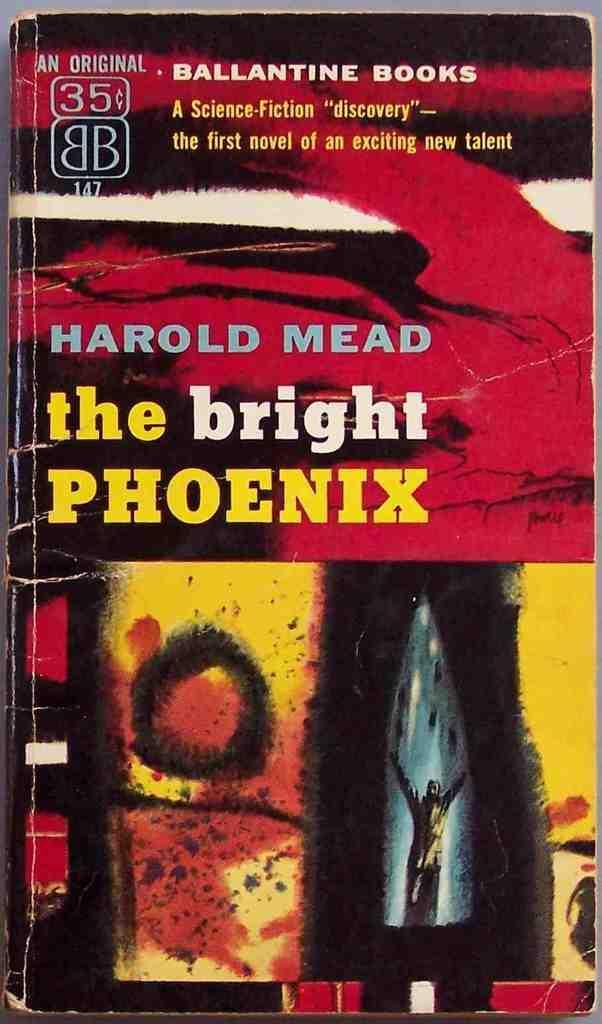Please provide a concise description of this image. In this image I can see a book cover page. Something is written on the book cover page. 